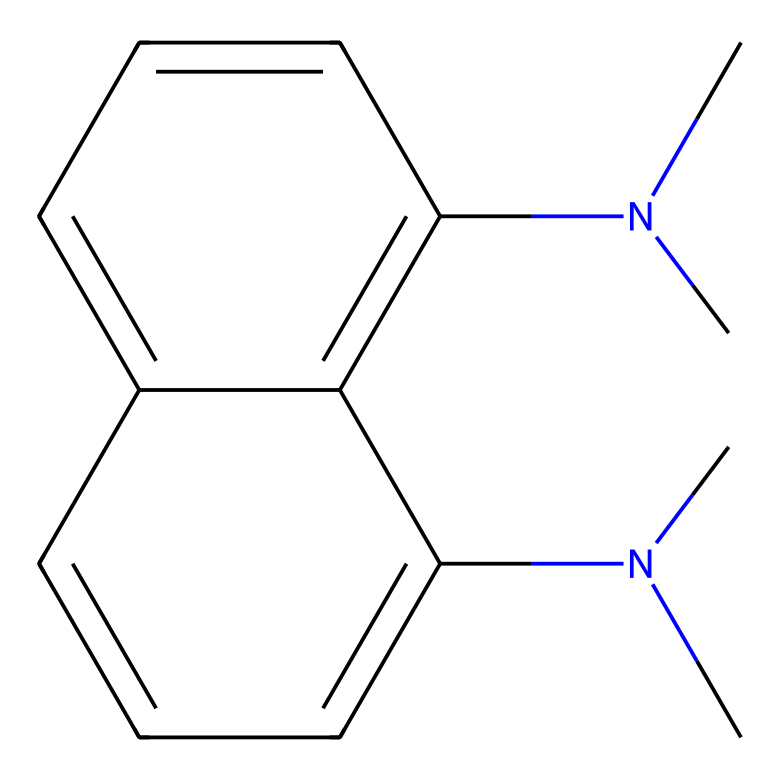What is the molecular formula of 1,8-bis(dimethylamino)naphthalene? The molecular formula can be determined by counting the number of each type of atom in the structure. The SMILES indicates that there are 12 carbon atoms (C), 16 hydrogen atoms (H), and 2 nitrogen atoms (N). Therefore, the molecular formula is C12H16N2.
Answer: C12H16N2 How many nitrogen atoms are present in the structure? The SMILES representation contains two instances of "N", indicating the presence of two nitrogen atoms in the structure.
Answer: 2 What type of chemical classification does 1,8-bis(dimethylamino)naphthalene belong to? This chemical is classified as a "proton sponge" due to its ability to absorb protons through the presence of nitrogen atoms in its structure. The dimethylamino groups enhance this property, making it a strong base.
Answer: proton sponge What is the significance of the dimethylamino groups in this compound? The dimethylamino groups serve as basic sites in the molecule, allowing it to act as a proton sponge. They can easily accept protons due to their lone pair of electrons, which significantly increases the basicity of the compound.
Answer: basic sites Where are the nitrogen atoms located in the molecular structure? The nitrogen atoms are located as substituents on the 1,8 positions of the naphthalene ring structure. They are part of the dimethylamino groups, which are directly attached to the aromatic naphthalene framework.
Answer: 1,8 positions 